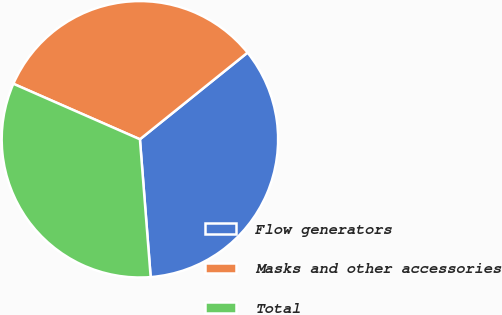Convert chart to OTSL. <chart><loc_0><loc_0><loc_500><loc_500><pie_chart><fcel>Flow generators<fcel>Masks and other accessories<fcel>Total<nl><fcel>34.55%<fcel>32.63%<fcel>32.82%<nl></chart> 